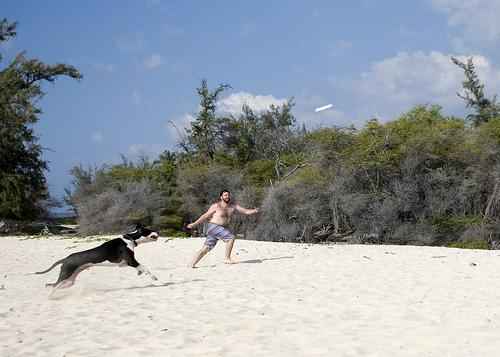Question: why is it bright?
Choices:
A. Flash.
B. It is sunny.
C. Neon paint.
D. Fire.
Answer with the letter. Answer: B Question: who chases the frisbee?
Choices:
A. Rod Stewart.
B. Kenny G.
C. The dog.
D. Yanni.
Answer with the letter. Answer: C 